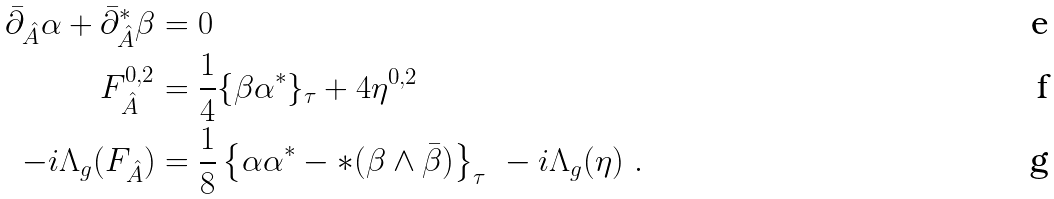Convert formula to latex. <formula><loc_0><loc_0><loc_500><loc_500>\bar { \partial } _ { \hat { A } } \alpha + \bar { \partial } ^ { * } _ { \hat { A } } \beta & = 0 \\ F _ { \hat { A } } ^ { 0 , 2 } & = \frac { 1 } { 4 } \{ \beta \alpha ^ { * } \} _ { \tau } + 4 \eta ^ { 0 , 2 } \\ - i \Lambda _ { g } ( F _ { \hat { A } } ) & = \frac { 1 } { 8 } \left \{ \alpha \alpha ^ { * } - * ( \beta \wedge \bar { \beta } ) \right \} _ { \tau } \ - i \Lambda _ { g } ( \eta ) \ .</formula> 